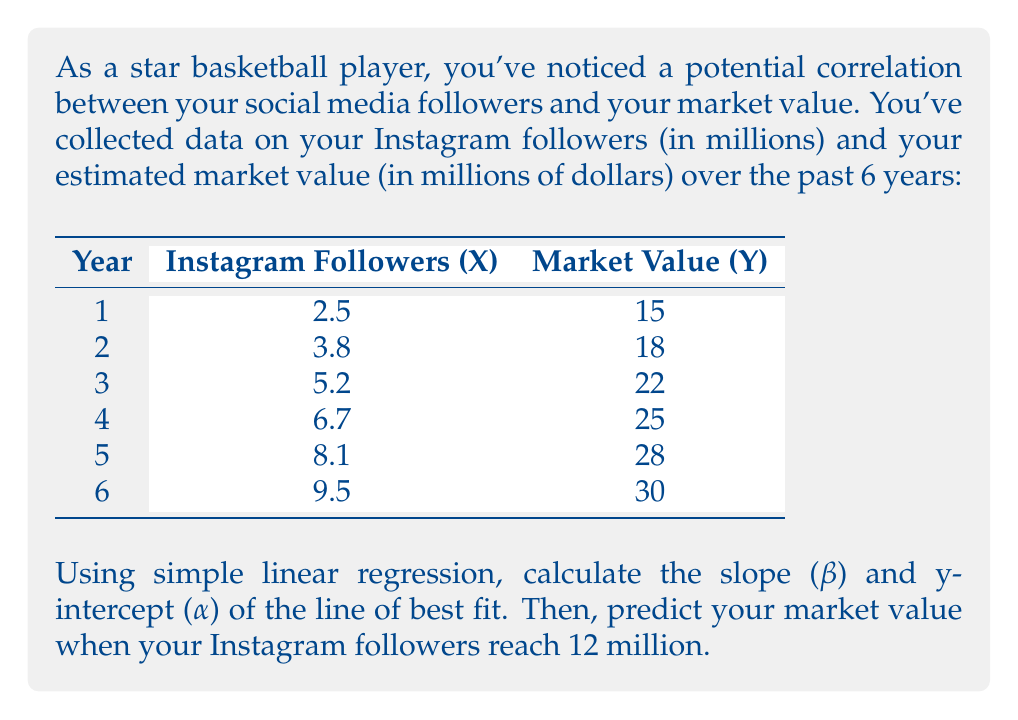Can you solve this math problem? To solve this problem, we'll use simple linear regression to find the line of best fit and then use it to make a prediction.

Step 1: Calculate the means of X and Y
$$\bar{X} = \frac{2.5 + 3.8 + 5.2 + 6.7 + 8.1 + 9.5}{6} = 5.97$$
$$\bar{Y} = \frac{15 + 18 + 22 + 25 + 28 + 30}{6} = 23$$

Step 2: Calculate the slope (β)
We use the formula: $$\beta = \frac{\sum(X_i - \bar{X})(Y_i - \bar{Y})}{\sum(X_i - \bar{X})^2}$$

Let's calculate the numerator and denominator separately:

Numerator:
$$(2.5 - 5.97)(15 - 23) + (3.8 - 5.97)(18 - 23) + ... + (9.5 - 5.97)(30 - 23) = 115.635$$

Denominator:
$$(2.5 - 5.97)^2 + (3.8 - 5.97)^2 + ... + (9.5 - 5.97)^2 = 52.9175$$

Now, we can calculate β:
$$\beta = \frac{115.635}{52.9175} = 2.185$$

Step 3: Calculate the y-intercept (α)
We use the formula: $$\alpha = \bar{Y} - \beta\bar{X}$$
$$\alpha = 23 - 2.185 * 5.97 = 9.96$$

Step 4: Write the equation of the line of best fit
$$Y = 2.185X + 9.96$$

Step 5: Predict the market value when Instagram followers reach 12 million
We substitute X = 12 into our equation:
$$Y = 2.185 * 12 + 9.96 = 36.18$$

Therefore, the predicted market value when Instagram followers reach 12 million is $36.18 million.
Answer: Slope (β) = 2.185
Y-intercept (α) = 9.96
Predicted market value at 12 million followers = $36.18 million 